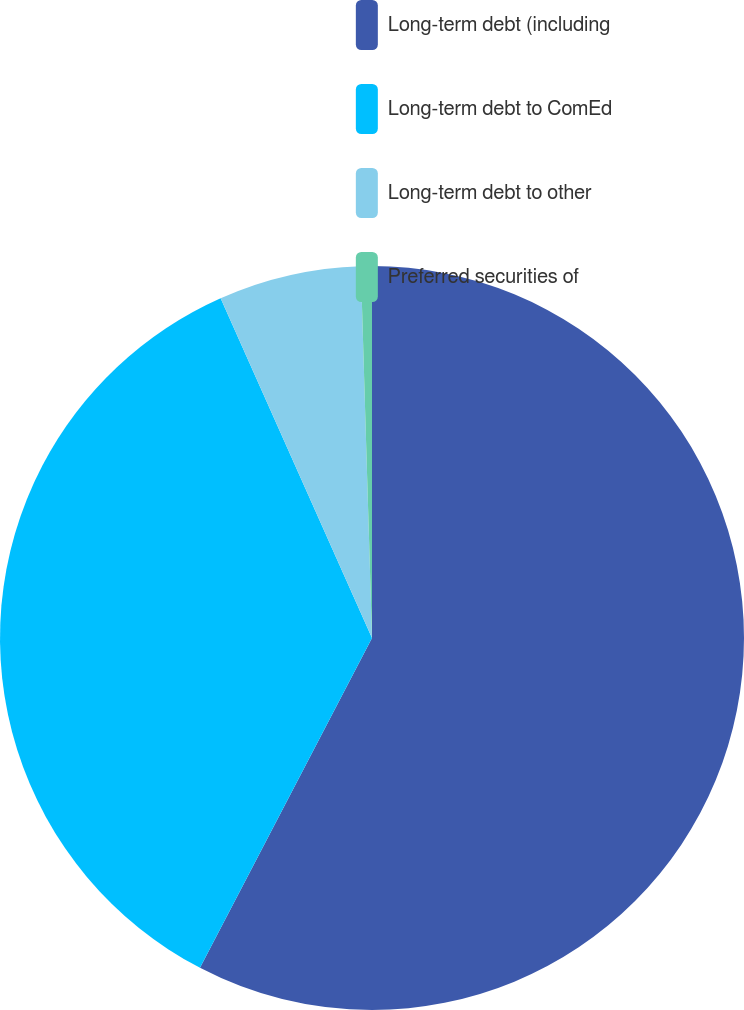<chart> <loc_0><loc_0><loc_500><loc_500><pie_chart><fcel>Long-term debt (including<fcel>Long-term debt to ComEd<fcel>Long-term debt to other<fcel>Preferred securities of<nl><fcel>57.65%<fcel>35.68%<fcel>6.19%<fcel>0.48%<nl></chart> 